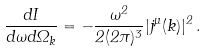<formula> <loc_0><loc_0><loc_500><loc_500>\frac { d I } { d \omega d \Omega _ { k } } = - \frac { \omega ^ { 2 } } { 2 ( 2 \pi ) ^ { 3 } } | j ^ { \mu } ( k ) | ^ { 2 } \, .</formula> 